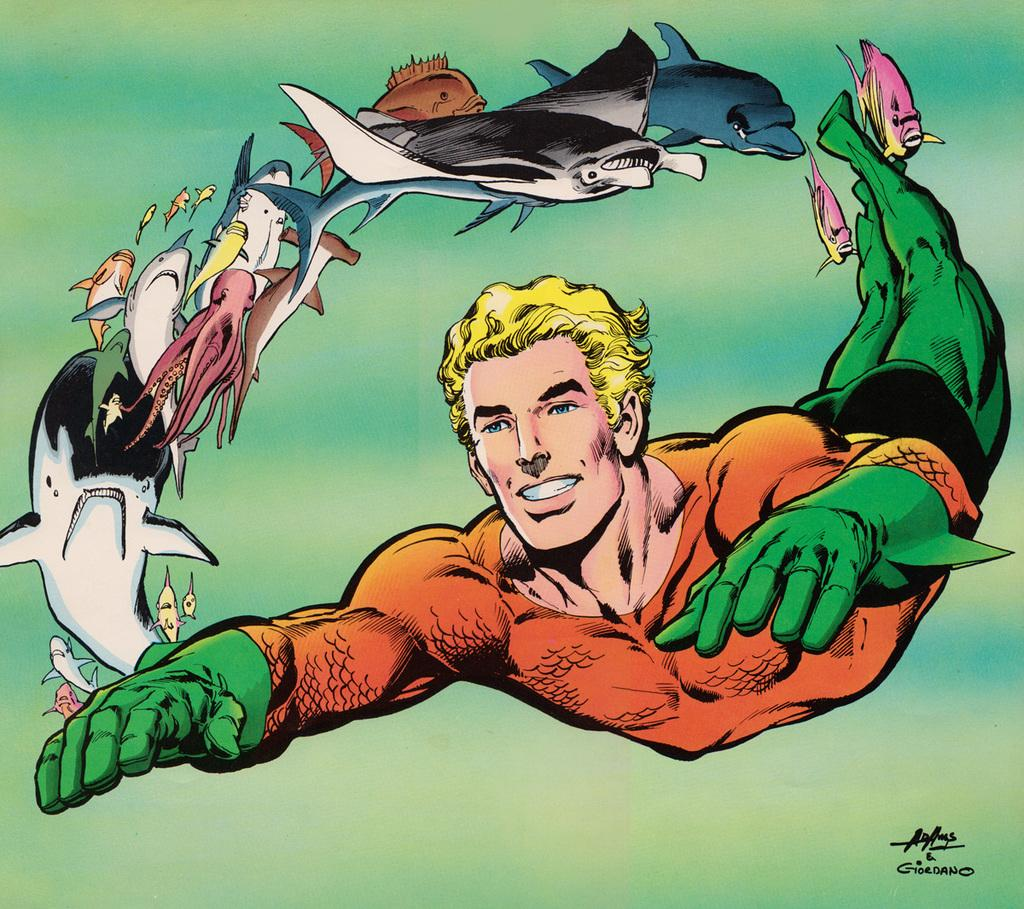What type of image is being described? The image is animated. What kind of sea creatures can be seen in the image? There are sea creatures flying in the air in the image. Is there any human presence in the image? Yes, there is a picture of a man in the image. Where can the stamp be found in the image? There is no stamp present in the image. Can you describe the cup that is visible in the image? There is no cup present in the image. 